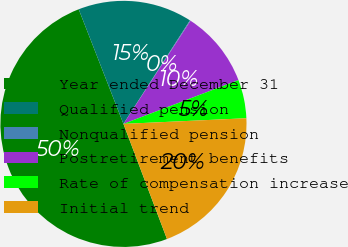Convert chart to OTSL. <chart><loc_0><loc_0><loc_500><loc_500><pie_chart><fcel>Year ended December 31<fcel>Qualified pension<fcel>Nonqualified pension<fcel>Postretirement benefits<fcel>Rate of compensation increase<fcel>Initial trend<nl><fcel>49.83%<fcel>15.01%<fcel>0.09%<fcel>10.03%<fcel>5.06%<fcel>19.98%<nl></chart> 